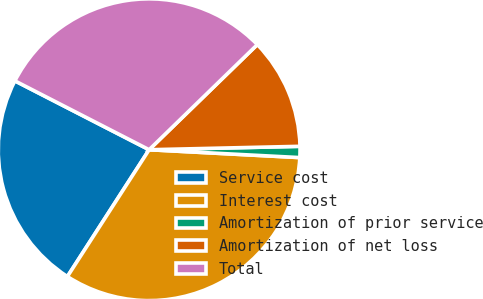<chart> <loc_0><loc_0><loc_500><loc_500><pie_chart><fcel>Service cost<fcel>Interest cost<fcel>Amortization of prior service<fcel>Amortization of net loss<fcel>Total<nl><fcel>23.43%<fcel>33.28%<fcel>1.19%<fcel>11.91%<fcel>30.18%<nl></chart> 